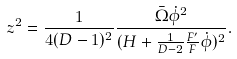<formula> <loc_0><loc_0><loc_500><loc_500>z ^ { 2 } = \frac { 1 } { 4 ( D - 1 ) ^ { 2 } } \frac { \bar { \Omega } \dot { \phi } ^ { 2 } } { ( H + \frac { 1 } { D - 2 } \frac { F ^ { \prime } } { F } \dot { \phi } ) ^ { 2 } } .</formula> 